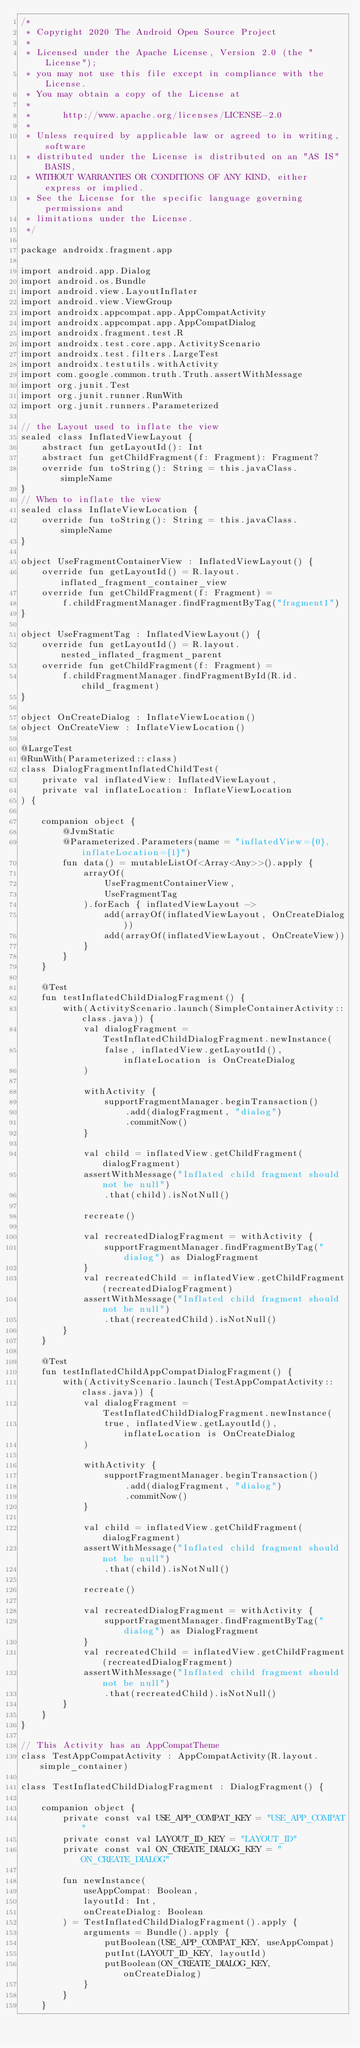<code> <loc_0><loc_0><loc_500><loc_500><_Kotlin_>/*
 * Copyright 2020 The Android Open Source Project
 *
 * Licensed under the Apache License, Version 2.0 (the "License");
 * you may not use this file except in compliance with the License.
 * You may obtain a copy of the License at
 *
 *      http://www.apache.org/licenses/LICENSE-2.0
 *
 * Unless required by applicable law or agreed to in writing, software
 * distributed under the License is distributed on an "AS IS" BASIS,
 * WITHOUT WARRANTIES OR CONDITIONS OF ANY KIND, either express or implied.
 * See the License for the specific language governing permissions and
 * limitations under the License.
 */

package androidx.fragment.app

import android.app.Dialog
import android.os.Bundle
import android.view.LayoutInflater
import android.view.ViewGroup
import androidx.appcompat.app.AppCompatActivity
import androidx.appcompat.app.AppCompatDialog
import androidx.fragment.test.R
import androidx.test.core.app.ActivityScenario
import androidx.test.filters.LargeTest
import androidx.testutils.withActivity
import com.google.common.truth.Truth.assertWithMessage
import org.junit.Test
import org.junit.runner.RunWith
import org.junit.runners.Parameterized

// the Layout used to inflate the view
sealed class InflatedViewLayout {
    abstract fun getLayoutId(): Int
    abstract fun getChildFragment(f: Fragment): Fragment?
    override fun toString(): String = this.javaClass.simpleName
}
// When to inflate the view
sealed class InflateViewLocation {
    override fun toString(): String = this.javaClass.simpleName
}

object UseFragmentContainerView : InflatedViewLayout() {
    override fun getLayoutId() = R.layout.inflated_fragment_container_view
    override fun getChildFragment(f: Fragment) =
        f.childFragmentManager.findFragmentByTag("fragment1")
}

object UseFragmentTag : InflatedViewLayout() {
    override fun getLayoutId() = R.layout.nested_inflated_fragment_parent
    override fun getChildFragment(f: Fragment) =
        f.childFragmentManager.findFragmentById(R.id.child_fragment)
}

object OnCreateDialog : InflateViewLocation()
object OnCreateView : InflateViewLocation()

@LargeTest
@RunWith(Parameterized::class)
class DialogFragmentInflatedChildTest(
    private val inflatedView: InflatedViewLayout,
    private val inflateLocation: InflateViewLocation
) {

    companion object {
        @JvmStatic
        @Parameterized.Parameters(name = "inflatedView={0}, inflateLocation={1}")
        fun data() = mutableListOf<Array<Any>>().apply {
            arrayOf(
                UseFragmentContainerView,
                UseFragmentTag
            ).forEach { inflatedViewLayout ->
                add(arrayOf(inflatedViewLayout, OnCreateDialog))
                add(arrayOf(inflatedViewLayout, OnCreateView))
            }
        }
    }

    @Test
    fun testInflatedChildDialogFragment() {
        with(ActivityScenario.launch(SimpleContainerActivity::class.java)) {
            val dialogFragment = TestInflatedChildDialogFragment.newInstance(
                false, inflatedView.getLayoutId(), inflateLocation is OnCreateDialog
            )

            withActivity {
                supportFragmentManager.beginTransaction()
                    .add(dialogFragment, "dialog")
                    .commitNow()
            }

            val child = inflatedView.getChildFragment(dialogFragment)
            assertWithMessage("Inflated child fragment should not be null")
                .that(child).isNotNull()

            recreate()

            val recreatedDialogFragment = withActivity {
                supportFragmentManager.findFragmentByTag("dialog") as DialogFragment
            }
            val recreatedChild = inflatedView.getChildFragment(recreatedDialogFragment)
            assertWithMessage("Inflated child fragment should not be null")
                .that(recreatedChild).isNotNull()
        }
    }

    @Test
    fun testInflatedChildAppCompatDialogFragment() {
        with(ActivityScenario.launch(TestAppCompatActivity::class.java)) {
            val dialogFragment = TestInflatedChildDialogFragment.newInstance(
                true, inflatedView.getLayoutId(), inflateLocation is OnCreateDialog
            )

            withActivity {
                supportFragmentManager.beginTransaction()
                    .add(dialogFragment, "dialog")
                    .commitNow()
            }

            val child = inflatedView.getChildFragment(dialogFragment)
            assertWithMessage("Inflated child fragment should not be null")
                .that(child).isNotNull()

            recreate()

            val recreatedDialogFragment = withActivity {
                supportFragmentManager.findFragmentByTag("dialog") as DialogFragment
            }
            val recreatedChild = inflatedView.getChildFragment(recreatedDialogFragment)
            assertWithMessage("Inflated child fragment should not be null")
                .that(recreatedChild).isNotNull()
        }
    }
}

// This Activity has an AppCompatTheme
class TestAppCompatActivity : AppCompatActivity(R.layout.simple_container)

class TestInflatedChildDialogFragment : DialogFragment() {

    companion object {
        private const val USE_APP_COMPAT_KEY = "USE_APP_COMPAT"
        private const val LAYOUT_ID_KEY = "LAYOUT_ID"
        private const val ON_CREATE_DIALOG_KEY = "ON_CREATE_DIALOG"

        fun newInstance(
            useAppCompat: Boolean,
            layoutId: Int,
            onCreateDialog: Boolean
        ) = TestInflatedChildDialogFragment().apply {
            arguments = Bundle().apply {
                putBoolean(USE_APP_COMPAT_KEY, useAppCompat)
                putInt(LAYOUT_ID_KEY, layoutId)
                putBoolean(ON_CREATE_DIALOG_KEY, onCreateDialog)
            }
        }
    }
</code> 